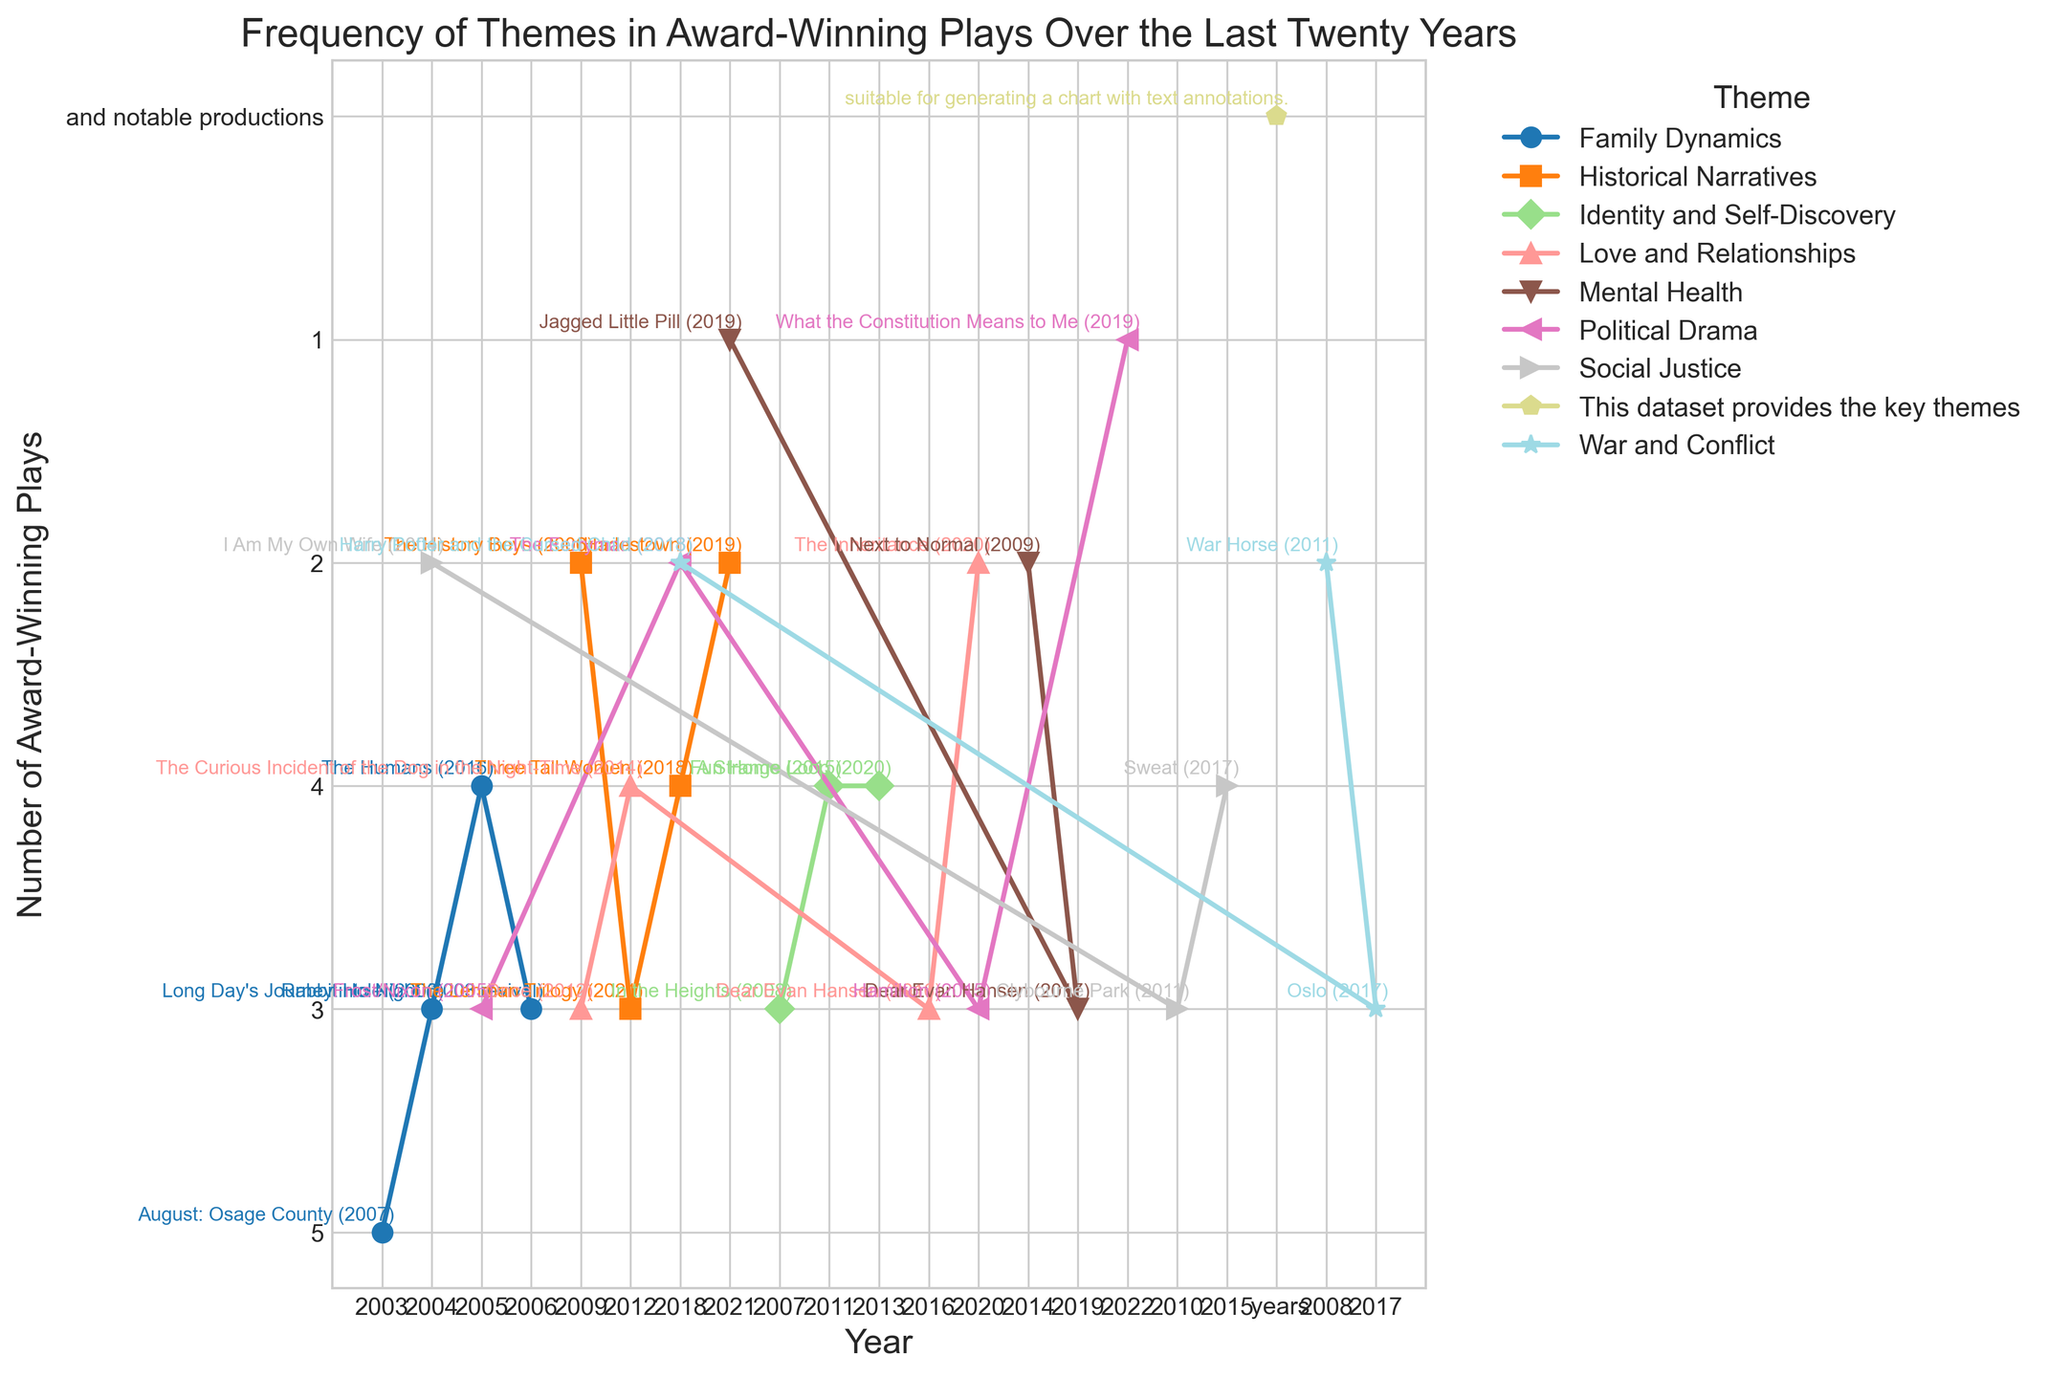What's the most commonly recurring theme in award-winning plays between 2000 and 2020? To find the most commonly recurring theme, we sum the number of award-winning plays for each theme and identify the theme with the highest total across the years. By examining the plot, "Family Dynamics" appears frequently with consistent high numbers over different years.
Answer: Family Dynamics Which theme saw the greatest increase in the number of award-winning plays from one year to the next? To answer this, we look for the steepest upward trend between consecutive points on the plot lines of different themes. "Social Justice" from 2004 to 2010 shows a significant increase, jumping from 2 to 3 plays.
Answer: Social Justice In which year did the theme "Identity and Self-Discovery" have the highest number of award-winning plays, and what was the noteworthy production? By examining the plot annotations for "Identity and Self-Discovery," we find that in 2013, the theme had 4 award-winning plays, with the noteworthy production being "A Strange Loop (2020)."
Answer: 2013, "A Strange Loop (2020)" Compare the number of award-winning plays with the theme "War and Conflict" from 2008 to 2018. What trend do you observe? We look at the plot for "War and Conflict." In 2008, there are 2 plays, followed by an increase to 3 plays in 2017, and then a decrease back to 2 plays in 2018. The trend observed is a rise followed by a fall.
Answer: Increase, then decrease What is the average number of award-winning plays with the theme "Political Drama" across the years it appears? By summing the number of award-winning plays for "Political Drama" and dividing by the number of years, we get (3 + 2 + 3 + 1) / 4 = 2.25.
Answer: 2.25 Which year featured the most diverse range of themes in award-winning plays? This requires identifying the year with the highest number of different themes. By examining the number of unique colored markers and text annotations in each year, 2018 seems to have the most diverse range with multiple themes like "War and Conflict," "Historical Narratives," and "Political Drama."
Answer: 2018 How did the frequency of the theme "Love and Relationships" change from 2012 to 2020? To find this out, we compare the plot points for "Love and Relationships." It had 3 plays in 2009, 4 in 2012, 3 in 2016, and 2 in 2020. There is an increase from 2009 to 2012, a slight drop in 2016, and further decrease in 2020.
Answer: Increased, then decreased Is there a theme that only appears in the award-winning plays for a single year? If so, identify the theme and the year. By scanning the plot for themes and years, "Political Drama" in 2022 with "What the Constitution Means to Me (2019)" is the only instance where a theme appears just once.
Answer: Political Drama, 2022 Which two themes have the closest number of award-winning plays in any given year, and what are the respective numbers? By looking for closely spaced points on the y-axis at the same year between two themes, in 2004 "Family Dynamics" has 3 and "Social Justice" has 2, which are close.
Answer: Family Dynamics (3), Social Justice (2) What notable production is associated with the peak in the theme "Mental Health"? By identifying the peak for "Mental Health" on the plot, in 2019, it has 3 plays with the noteworthy production being "Dear Evan Hansen (2017)."
Answer: Dear Evan Hansen (2017) 